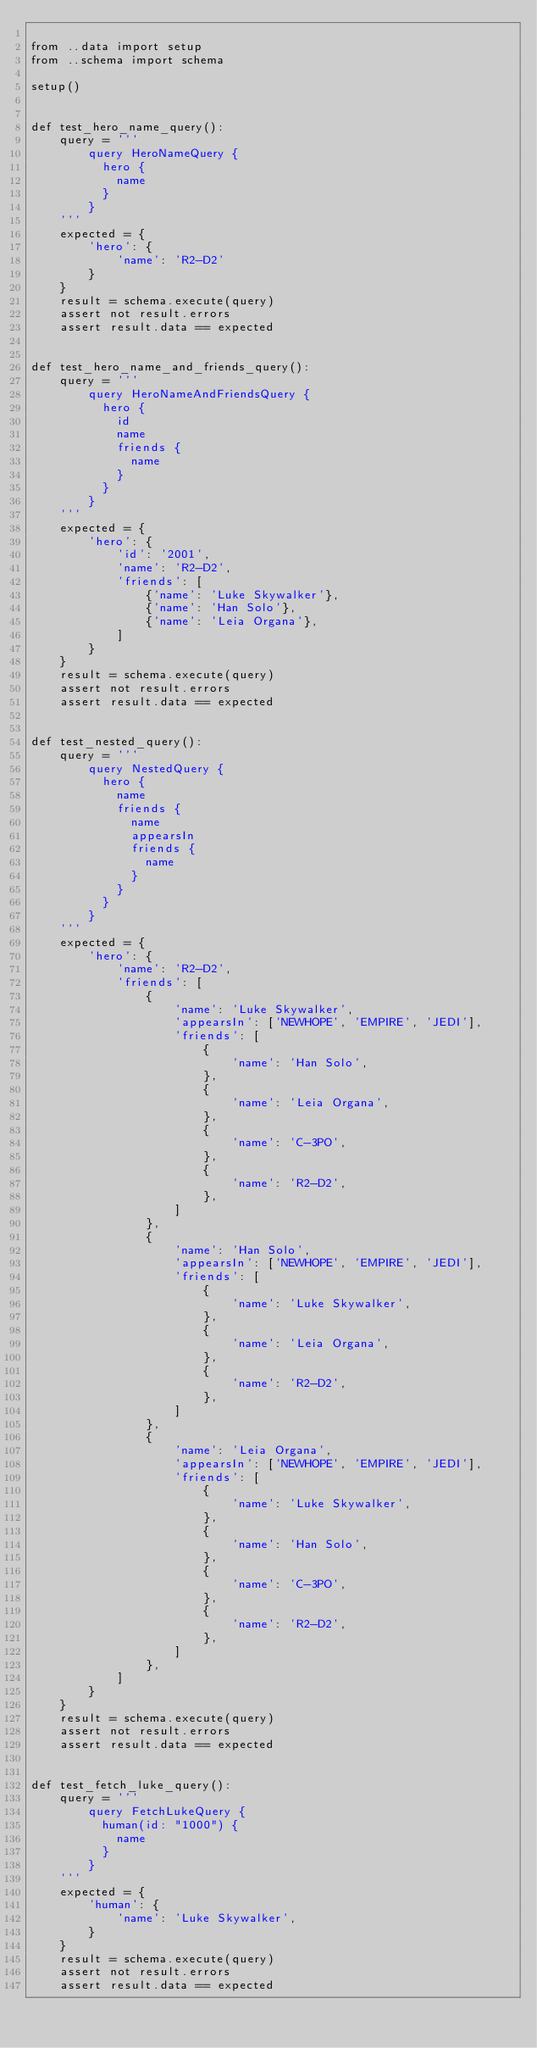<code> <loc_0><loc_0><loc_500><loc_500><_Python_>
from ..data import setup
from ..schema import schema

setup()


def test_hero_name_query():
    query = '''
        query HeroNameQuery {
          hero {
            name
          }
        }
    '''
    expected = {
        'hero': {
            'name': 'R2-D2'
        }
    }
    result = schema.execute(query)
    assert not result.errors
    assert result.data == expected


def test_hero_name_and_friends_query():
    query = '''
        query HeroNameAndFriendsQuery {
          hero {
            id
            name
            friends {
              name
            }
          }
        }
    '''
    expected = {
        'hero': {
            'id': '2001',
            'name': 'R2-D2',
            'friends': [
                {'name': 'Luke Skywalker'},
                {'name': 'Han Solo'},
                {'name': 'Leia Organa'},
            ]
        }
    }
    result = schema.execute(query)
    assert not result.errors
    assert result.data == expected


def test_nested_query():
    query = '''
        query NestedQuery {
          hero {
            name
            friends {
              name
              appearsIn
              friends {
                name
              }
            }
          }
        }
    '''
    expected = {
        'hero': {
            'name': 'R2-D2',
            'friends': [
                {
                    'name': 'Luke Skywalker',
                    'appearsIn': ['NEWHOPE', 'EMPIRE', 'JEDI'],
                    'friends': [
                        {
                            'name': 'Han Solo',
                        },
                        {
                            'name': 'Leia Organa',
                        },
                        {
                            'name': 'C-3PO',
                        },
                        {
                            'name': 'R2-D2',
                        },
                    ]
                },
                {
                    'name': 'Han Solo',
                    'appearsIn': ['NEWHOPE', 'EMPIRE', 'JEDI'],
                    'friends': [
                        {
                            'name': 'Luke Skywalker',
                        },
                        {
                            'name': 'Leia Organa',
                        },
                        {
                            'name': 'R2-D2',
                        },
                    ]
                },
                {
                    'name': 'Leia Organa',
                    'appearsIn': ['NEWHOPE', 'EMPIRE', 'JEDI'],
                    'friends': [
                        {
                            'name': 'Luke Skywalker',
                        },
                        {
                            'name': 'Han Solo',
                        },
                        {
                            'name': 'C-3PO',
                        },
                        {
                            'name': 'R2-D2',
                        },
                    ]
                },
            ]
        }
    }
    result = schema.execute(query)
    assert not result.errors
    assert result.data == expected


def test_fetch_luke_query():
    query = '''
        query FetchLukeQuery {
          human(id: "1000") {
            name
          }
        }
    '''
    expected = {
        'human': {
            'name': 'Luke Skywalker',
        }
    }
    result = schema.execute(query)
    assert not result.errors
    assert result.data == expected

</code> 